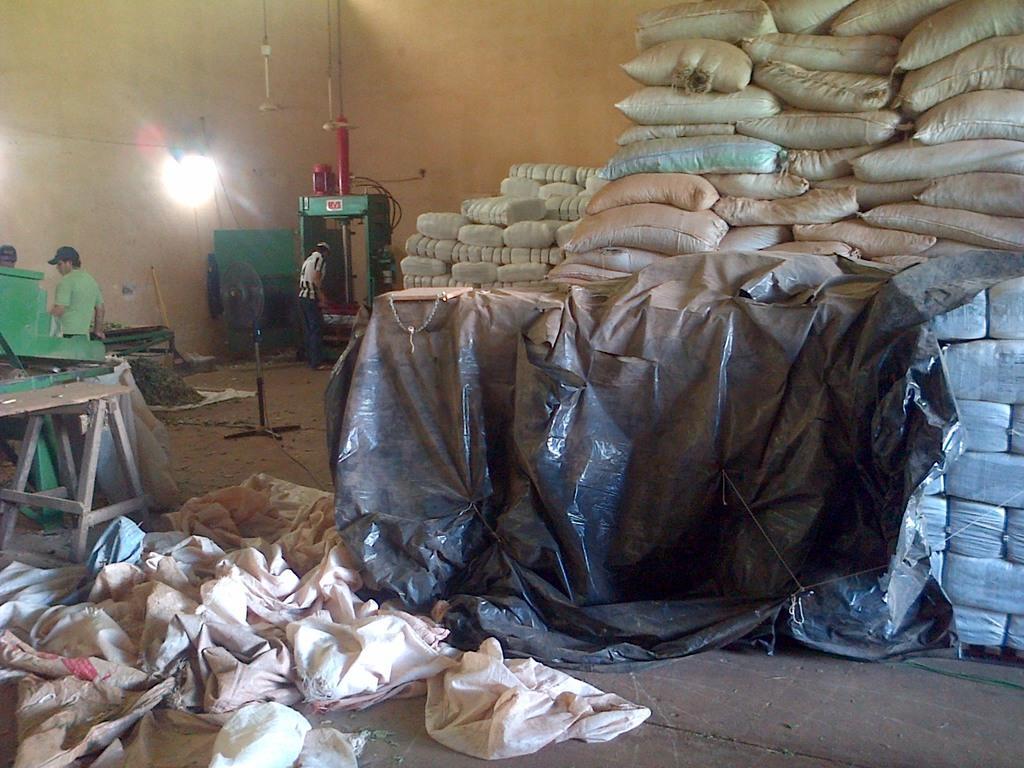Could you give a brief overview of what you see in this image? This is the picture of a room. On the right side of the image there are bags and the bags are covered with sheet. In the foreground there are empty bags. At the back there are three persons standing and there are machines and there is a table and fan and there is a light on the wall. At the bottom there is a floor. 